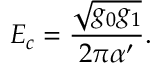<formula> <loc_0><loc_0><loc_500><loc_500>E _ { c } = \frac { \sqrt { g _ { 0 } g _ { 1 } } } { 2 \pi \alpha ^ { \prime } } .</formula> 